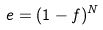<formula> <loc_0><loc_0><loc_500><loc_500>e = ( 1 - f ) ^ { N }</formula> 